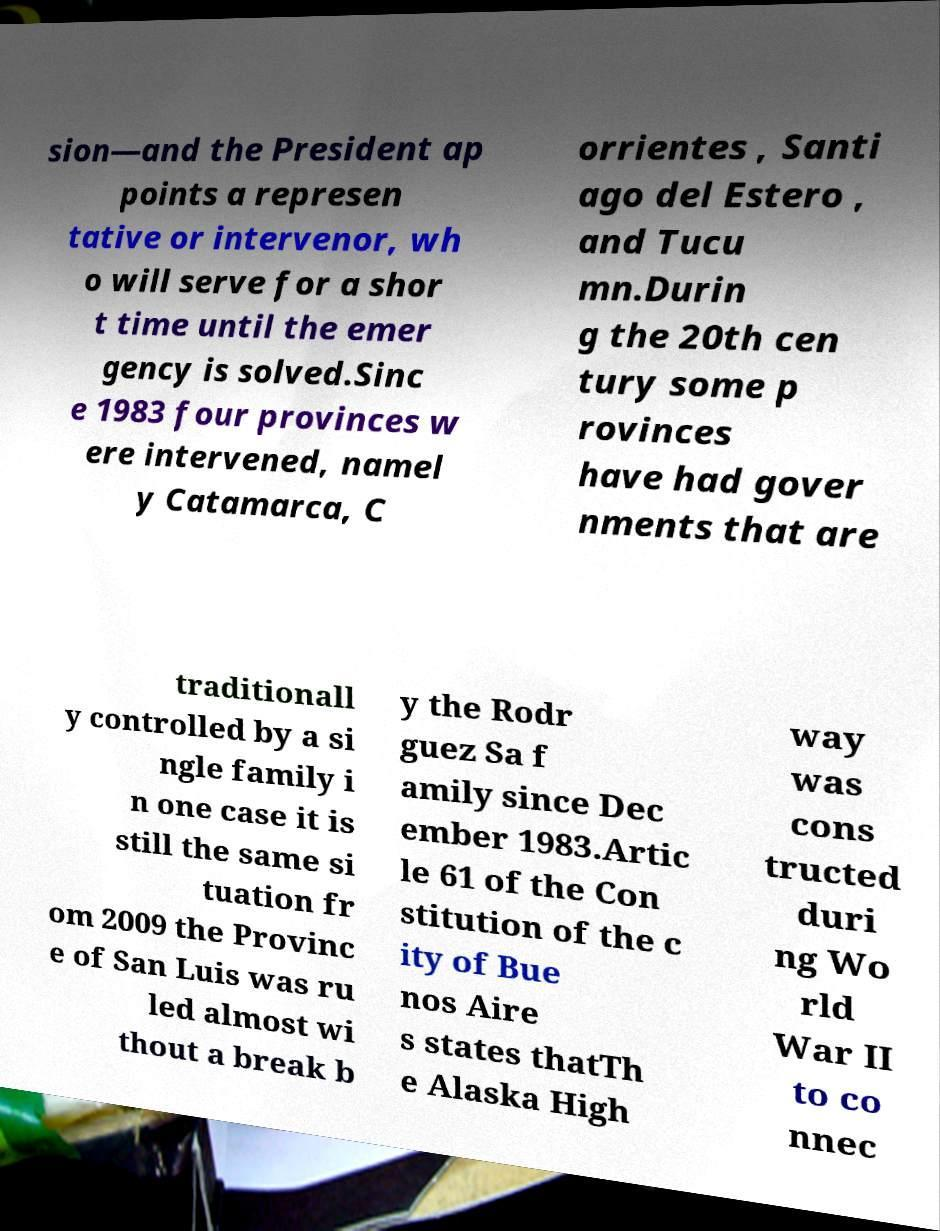I need the written content from this picture converted into text. Can you do that? sion—and the President ap points a represen tative or intervenor, wh o will serve for a shor t time until the emer gency is solved.Sinc e 1983 four provinces w ere intervened, namel y Catamarca, C orrientes , Santi ago del Estero , and Tucu mn.Durin g the 20th cen tury some p rovinces have had gover nments that are traditionall y controlled by a si ngle family i n one case it is still the same si tuation fr om 2009 the Provinc e of San Luis was ru led almost wi thout a break b y the Rodr guez Sa f amily since Dec ember 1983.Artic le 61 of the Con stitution of the c ity of Bue nos Aire s states thatTh e Alaska High way was cons tructed duri ng Wo rld War II to co nnec 